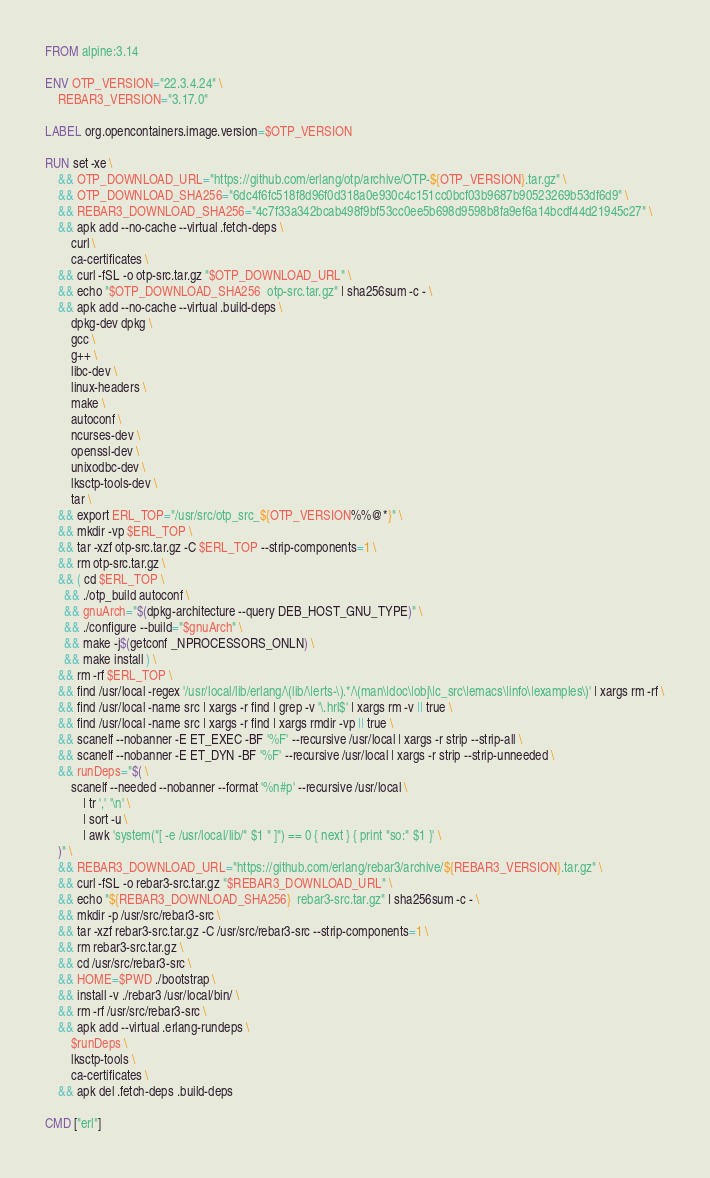<code> <loc_0><loc_0><loc_500><loc_500><_Dockerfile_>FROM alpine:3.14

ENV OTP_VERSION="22.3.4.24" \
    REBAR3_VERSION="3.17.0"

LABEL org.opencontainers.image.version=$OTP_VERSION

RUN set -xe \
	&& OTP_DOWNLOAD_URL="https://github.com/erlang/otp/archive/OTP-${OTP_VERSION}.tar.gz" \
	&& OTP_DOWNLOAD_SHA256="6dc4f6fc518f8d96f0d318a0e930c4c151cc0bcf03b9687b90523269b53df6d9" \
	&& REBAR3_DOWNLOAD_SHA256="4c7f33a342bcab498f9bf53cc0ee5b698d9598b8fa9ef6a14bcdf44d21945c27" \
	&& apk add --no-cache --virtual .fetch-deps \
		curl \
		ca-certificates \
	&& curl -fSL -o otp-src.tar.gz "$OTP_DOWNLOAD_URL" \
	&& echo "$OTP_DOWNLOAD_SHA256  otp-src.tar.gz" | sha256sum -c - \
	&& apk add --no-cache --virtual .build-deps \
		dpkg-dev dpkg \
		gcc \
		g++ \
		libc-dev \
		linux-headers \
		make \
		autoconf \
		ncurses-dev \
		openssl-dev \
		unixodbc-dev \
		lksctp-tools-dev \
		tar \
	&& export ERL_TOP="/usr/src/otp_src_${OTP_VERSION%%@*}" \
	&& mkdir -vp $ERL_TOP \
	&& tar -xzf otp-src.tar.gz -C $ERL_TOP --strip-components=1 \
	&& rm otp-src.tar.gz \
	&& ( cd $ERL_TOP \
	  && ./otp_build autoconf \
	  && gnuArch="$(dpkg-architecture --query DEB_HOST_GNU_TYPE)" \
	  && ./configure --build="$gnuArch" \
	  && make -j$(getconf _NPROCESSORS_ONLN) \
	  && make install ) \
	&& rm -rf $ERL_TOP \
	&& find /usr/local -regex '/usr/local/lib/erlang/\(lib/\|erts-\).*/\(man\|doc\|obj\|c_src\|emacs\|info\|examples\)' | xargs rm -rf \
	&& find /usr/local -name src | xargs -r find | grep -v '\.hrl$' | xargs rm -v || true \
	&& find /usr/local -name src | xargs -r find | xargs rmdir -vp || true \
	&& scanelf --nobanner -E ET_EXEC -BF '%F' --recursive /usr/local | xargs -r strip --strip-all \
	&& scanelf --nobanner -E ET_DYN -BF '%F' --recursive /usr/local | xargs -r strip --strip-unneeded \
	&& runDeps="$( \
		scanelf --needed --nobanner --format '%n#p' --recursive /usr/local \
			| tr ',' '\n' \
			| sort -u \
			| awk 'system("[ -e /usr/local/lib/" $1 " ]") == 0 { next } { print "so:" $1 }' \
	)" \
	&& REBAR3_DOWNLOAD_URL="https://github.com/erlang/rebar3/archive/${REBAR3_VERSION}.tar.gz" \
	&& curl -fSL -o rebar3-src.tar.gz "$REBAR3_DOWNLOAD_URL" \
	&& echo "${REBAR3_DOWNLOAD_SHA256}  rebar3-src.tar.gz" | sha256sum -c - \
	&& mkdir -p /usr/src/rebar3-src \
	&& tar -xzf rebar3-src.tar.gz -C /usr/src/rebar3-src --strip-components=1 \
	&& rm rebar3-src.tar.gz \
	&& cd /usr/src/rebar3-src \
	&& HOME=$PWD ./bootstrap \
	&& install -v ./rebar3 /usr/local/bin/ \
	&& rm -rf /usr/src/rebar3-src \
	&& apk add --virtual .erlang-rundeps \
		$runDeps \
		lksctp-tools \
		ca-certificates \
	&& apk del .fetch-deps .build-deps

CMD ["erl"]
</code> 